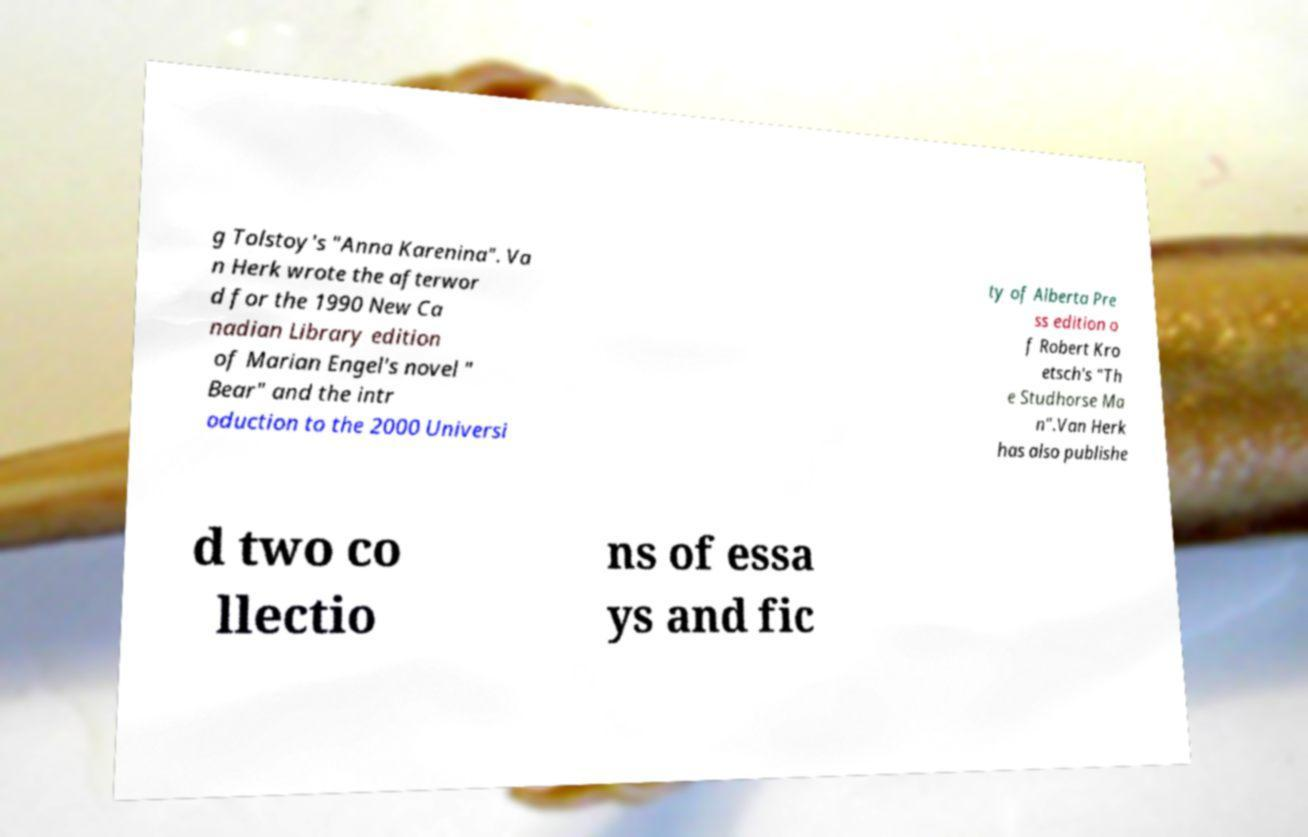There's text embedded in this image that I need extracted. Can you transcribe it verbatim? g Tolstoy's "Anna Karenina". Va n Herk wrote the afterwor d for the 1990 New Ca nadian Library edition of Marian Engel's novel " Bear" and the intr oduction to the 2000 Universi ty of Alberta Pre ss edition o f Robert Kro etsch's "Th e Studhorse Ma n".Van Herk has also publishe d two co llectio ns of essa ys and fic 